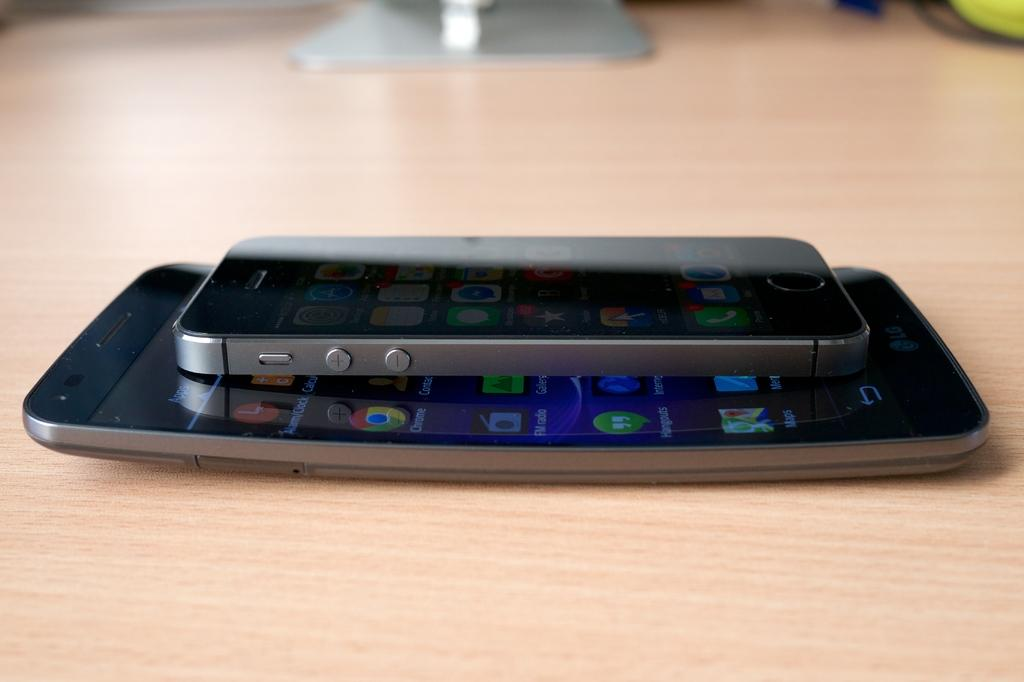How many mobile phones can be seen in the image? There are two mobile phones in the image. Where are the mobile phones located? The mobile phones are on a wooden plank. What can be seen on the screens of the mobile phones? The screens of the mobile phones have apps visible on them. What type of toothbrush is being used as a joke in the image? There is no toothbrush or joke present in the image. How much salt is visible on the wooden plank in the image? There is no salt visible in the image; it features two mobile phones on a wooden plank. 